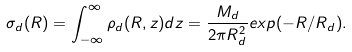<formula> <loc_0><loc_0><loc_500><loc_500>\sigma _ { d } ( R ) = \int _ { - \infty } ^ { \infty } \rho _ { d } ( R , z ) d z = \frac { M _ { d } } { 2 \pi R _ { d } ^ { 2 } } e x p ( - R / R _ { d } ) .</formula> 